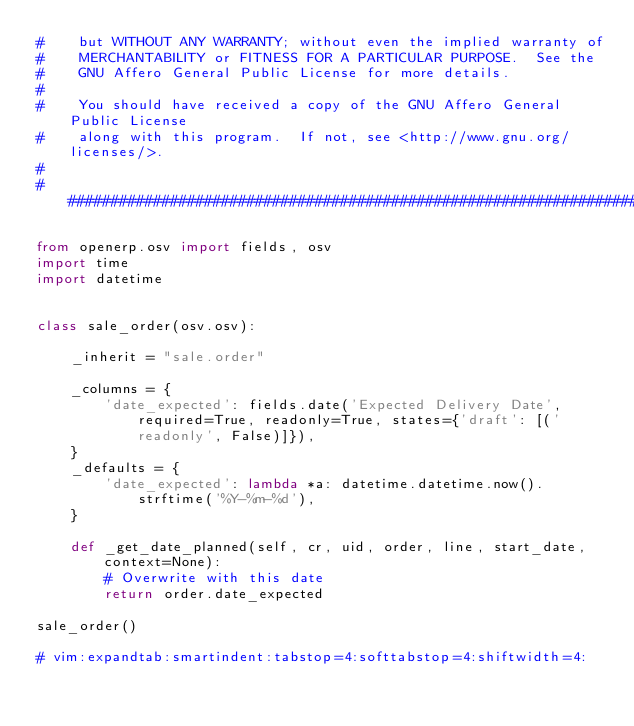<code> <loc_0><loc_0><loc_500><loc_500><_Python_>#    but WITHOUT ANY WARRANTY; without even the implied warranty of
#    MERCHANTABILITY or FITNESS FOR A PARTICULAR PURPOSE.  See the
#    GNU Affero General Public License for more details.
#
#    You should have received a copy of the GNU Affero General Public License
#    along with this program.  If not, see <http://www.gnu.org/licenses/>.
#
##############################################################################

from openerp.osv import fields, osv
import time
import datetime


class sale_order(osv.osv):

    _inherit = "sale.order"

    _columns = {
        'date_expected': fields.date('Expected Delivery Date', required=True, readonly=True, states={'draft': [('readonly', False)]}),
    }
    _defaults = {
        'date_expected': lambda *a: datetime.datetime.now().strftime('%Y-%m-%d'),
    }

    def _get_date_planned(self, cr, uid, order, line, start_date, context=None):
        # Overwrite with this date
        return order.date_expected

sale_order()

# vim:expandtab:smartindent:tabstop=4:softtabstop=4:shiftwidth=4:
</code> 